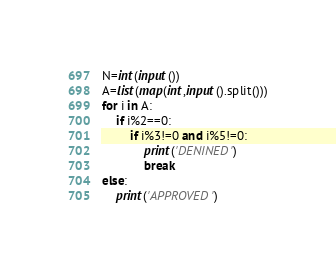Convert code to text. <code><loc_0><loc_0><loc_500><loc_500><_Python_>N=int(input())
A=list(map(int,input().split()))
for i in A:
    if i%2==0:
        if i%3!=0 and i%5!=0:
            print('DENINED')
            break
else:
    print('APPROVED')</code> 